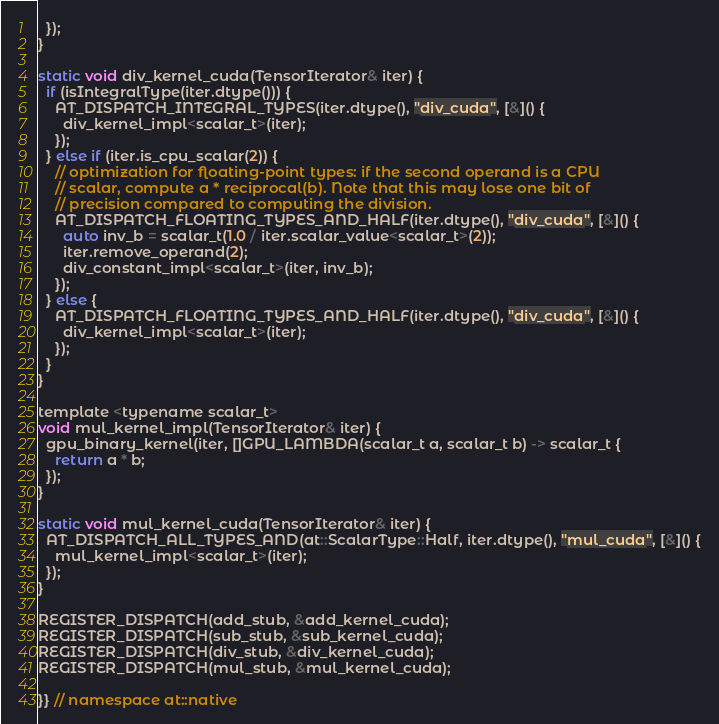Convert code to text. <code><loc_0><loc_0><loc_500><loc_500><_Cuda_>  });
}

static void div_kernel_cuda(TensorIterator& iter) {
  if (isIntegralType(iter.dtype())) {
    AT_DISPATCH_INTEGRAL_TYPES(iter.dtype(), "div_cuda", [&]() {
      div_kernel_impl<scalar_t>(iter);
    });
  } else if (iter.is_cpu_scalar(2)) {
    // optimization for floating-point types: if the second operand is a CPU
    // scalar, compute a * reciprocal(b). Note that this may lose one bit of
    // precision compared to computing the division.
    AT_DISPATCH_FLOATING_TYPES_AND_HALF(iter.dtype(), "div_cuda", [&]() {
      auto inv_b = scalar_t(1.0 / iter.scalar_value<scalar_t>(2));
      iter.remove_operand(2);
      div_constant_impl<scalar_t>(iter, inv_b);
    });
  } else {
    AT_DISPATCH_FLOATING_TYPES_AND_HALF(iter.dtype(), "div_cuda", [&]() {
      div_kernel_impl<scalar_t>(iter);
    });
  }
}

template <typename scalar_t>
void mul_kernel_impl(TensorIterator& iter) {
  gpu_binary_kernel(iter, []GPU_LAMBDA(scalar_t a, scalar_t b) -> scalar_t {
    return a * b;
  });
}

static void mul_kernel_cuda(TensorIterator& iter) {
  AT_DISPATCH_ALL_TYPES_AND(at::ScalarType::Half, iter.dtype(), "mul_cuda", [&]() {
    mul_kernel_impl<scalar_t>(iter);
  });
}

REGISTER_DISPATCH(add_stub, &add_kernel_cuda);
REGISTER_DISPATCH(sub_stub, &sub_kernel_cuda);
REGISTER_DISPATCH(div_stub, &div_kernel_cuda);
REGISTER_DISPATCH(mul_stub, &mul_kernel_cuda);

}} // namespace at::native
</code> 